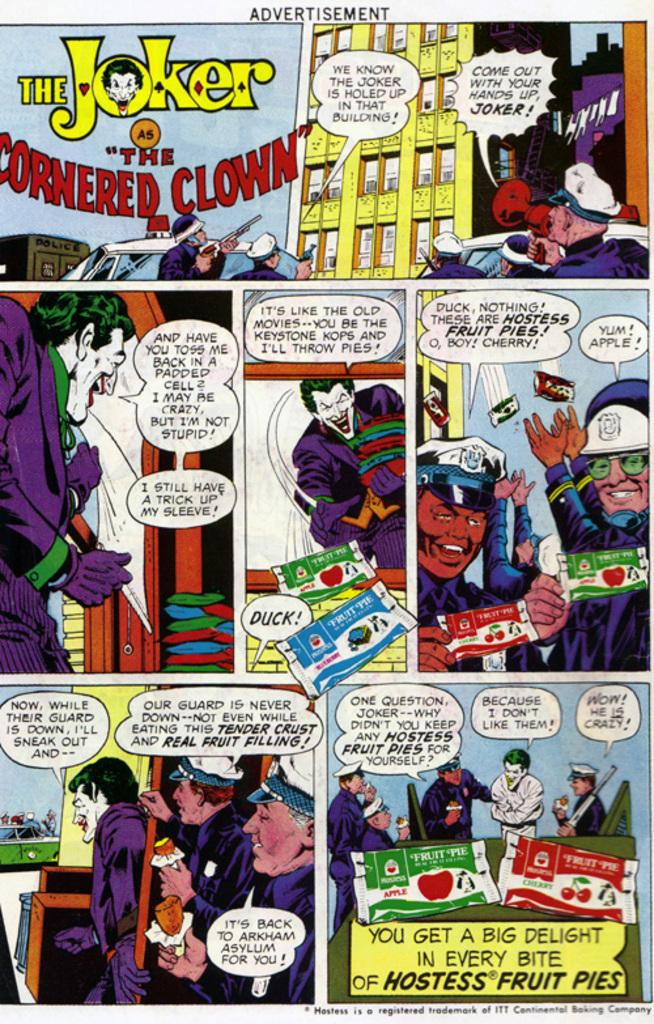<image>
Describe the image concisely. A comic is titled The Joker and the Cornered Clown. 